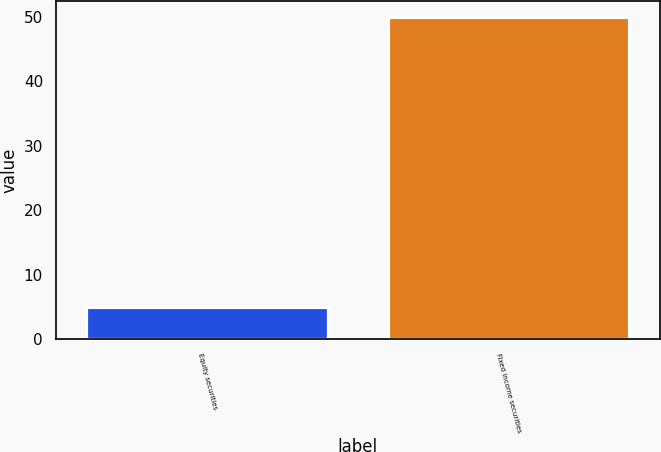Convert chart to OTSL. <chart><loc_0><loc_0><loc_500><loc_500><bar_chart><fcel>Equity securities<fcel>Fixed income securities<nl><fcel>5<fcel>50<nl></chart> 